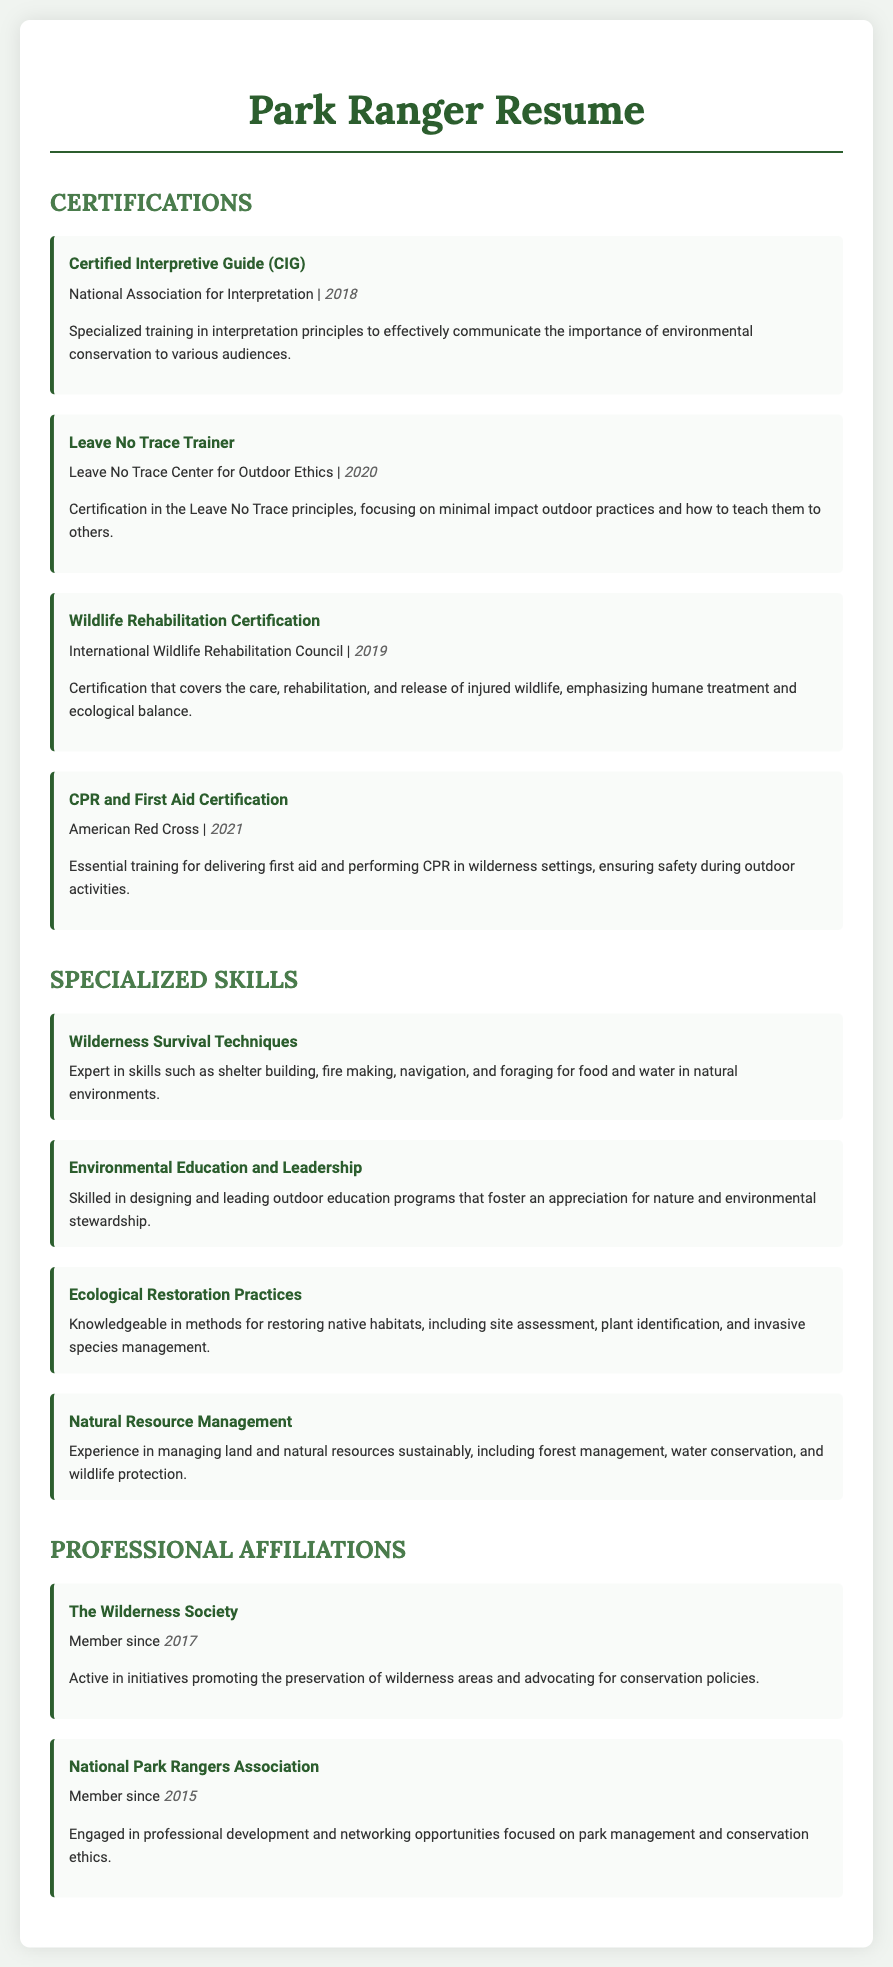what year was the Leave No Trace Trainer certification obtained? The Leave No Trace Trainer certification is noted to have been obtained in 2020.
Answer: 2020 which organization offers the Certified Interpretive Guide certification? The document states that the Certified Interpretive Guide certification is offered by the National Association for Interpretation.
Answer: National Association for Interpretation what specialized skill involves shelter building and fire making? The document describes Wilderness Survival Techniques as involving skills such as shelter building and fire making.
Answer: Wilderness Survival Techniques how many certifications are listed in the document? There are four certifications listed in the Certifications section of the document.
Answer: 4 which year did the member join The Wilderness Society? The membership year for The Wilderness Society is mentioned as 2017.
Answer: 2017 name one principle emphasized in the Leave No Trace Trainer certification. The certification emphasizes minimal impact outdoor practices.
Answer: minimal impact outdoor practices what is a key focus of the Environmental Education and Leadership skill? The focus of this skill is designing and leading outdoor education programs.
Answer: designing and leading outdoor education programs which organization does the CPR and First Aid Certification come from? The document indicates that the CPR and First Aid Certification is from the American Red Cross.
Answer: American Red Cross 